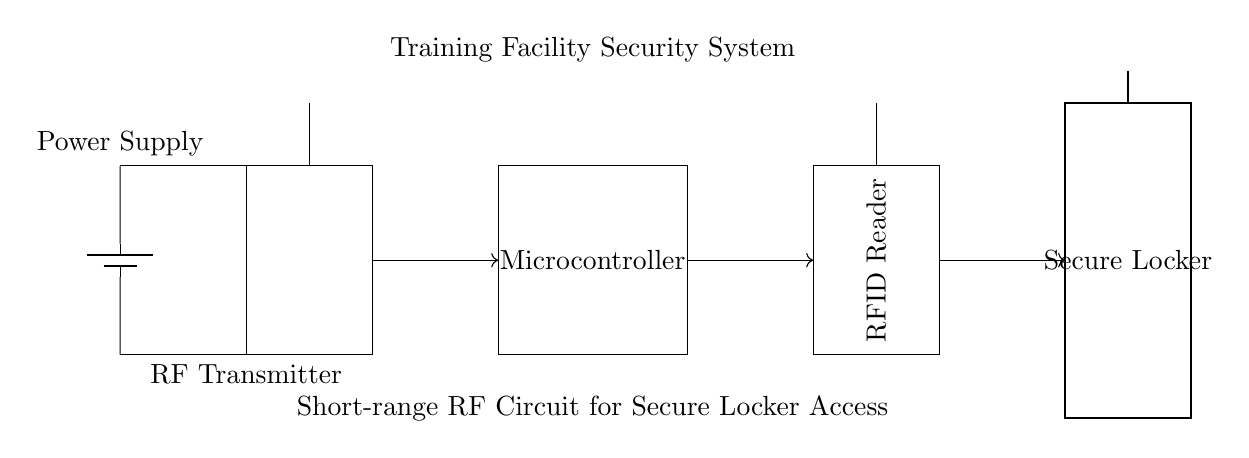What components are included in this circuit? The circuit consists of an RF Transmitter, Microcontroller, RFID Reader, Secure Locker, and a Power Supply. These components are clearly labeled within the circuit diagram.
Answer: RF Transmitter, Microcontroller, RFID Reader, Secure Locker, Power Supply What is the purpose of the RF Transmitter in this circuit? The RF Transmitter sends signals wirelessly to communicate with the RFID Reader, allowing for secure locker access. Its placement at the beginning of the circuit indicates its role in initiating communication.
Answer: Communication How does the RFID Reader receive information in this circuit? The RFID Reader receives information through the antenna located at the top, which captures signals from the RF Transmitter. The connection with the Microcontroller enables it to process the received signals.
Answer: Through the antenna Which component would likely manage access control? The Microcontroller is responsible for managing access control by processing signals received from the RFID Reader and controlling the state of the Secure Locker accordingly.
Answer: Microcontroller What is the power source used in this circuit? The circuit uses a battery as the power supply for all components, visible at the left side labeled as "Power Supply." This directs power to the RF Transmitter and Microcontroller.
Answer: Battery How are the components connected in this circuit? The components are connected with directional arrows indicating signal flow: from the RF Transmitter to the Microcontroller, then to the RFID Reader, and finally to the Secure Locker. This sequence outlines the communication process for secure access.
Answer: Directional arrows What type of communication does this circuit facilitate? The circuit facilitates short-range radio frequency communication, indicated by the use of an RF Transmitter and RFID Reader, which are typically used for secure access systems in close proximity.
Answer: Short-range radio frequency 